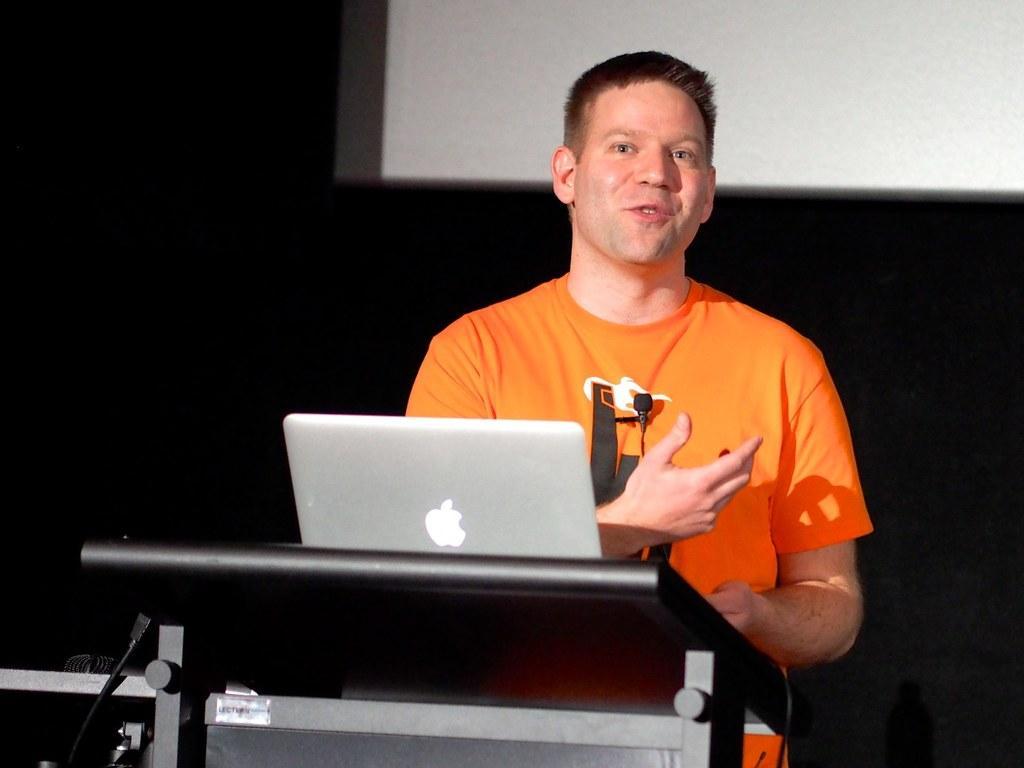Can you describe this image briefly? In this picture we can see a laptop on the podium. Behind the podium a man is standing and the he is in the orange t shirt. Behind the man, it looks like a projector screen and the dark background. 